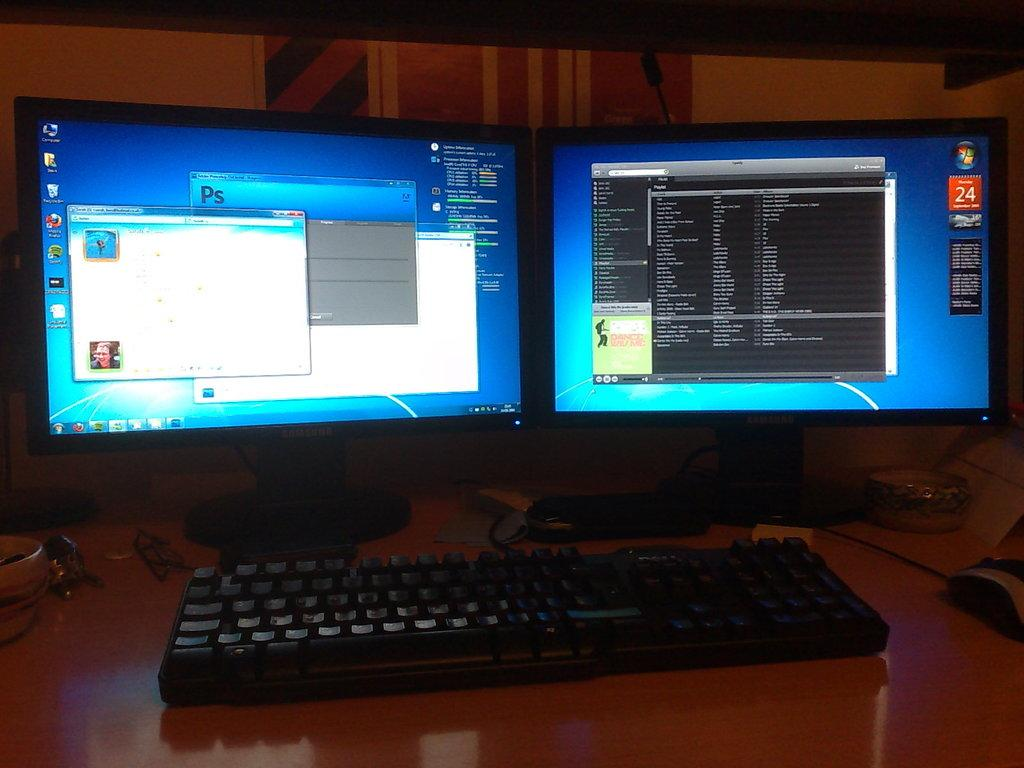<image>
Share a concise interpretation of the image provided. Double Monitoe and keyboard with a red box on the right of the screen with a white 24 printed. 